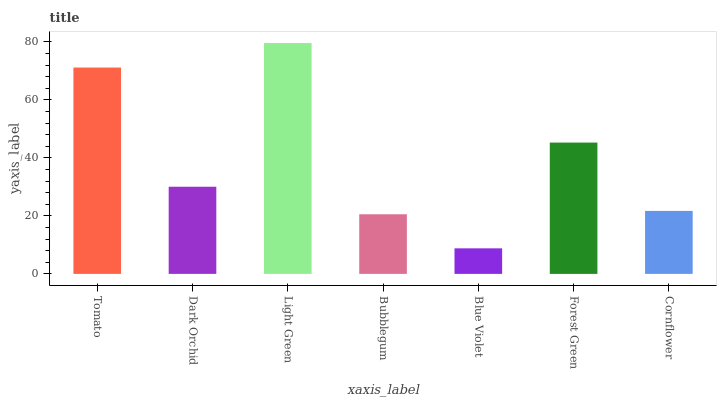Is Blue Violet the minimum?
Answer yes or no. Yes. Is Light Green the maximum?
Answer yes or no. Yes. Is Dark Orchid the minimum?
Answer yes or no. No. Is Dark Orchid the maximum?
Answer yes or no. No. Is Tomato greater than Dark Orchid?
Answer yes or no. Yes. Is Dark Orchid less than Tomato?
Answer yes or no. Yes. Is Dark Orchid greater than Tomato?
Answer yes or no. No. Is Tomato less than Dark Orchid?
Answer yes or no. No. Is Dark Orchid the high median?
Answer yes or no. Yes. Is Dark Orchid the low median?
Answer yes or no. Yes. Is Light Green the high median?
Answer yes or no. No. Is Light Green the low median?
Answer yes or no. No. 